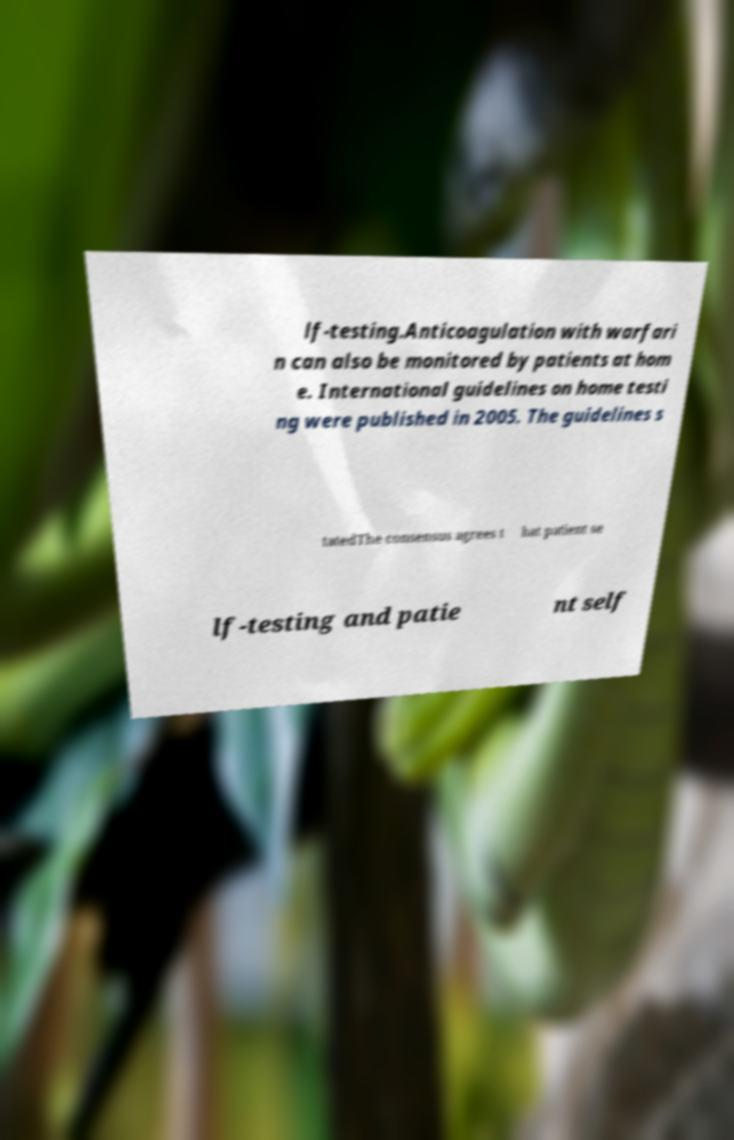Please read and relay the text visible in this image. What does it say? lf-testing.Anticoagulation with warfari n can also be monitored by patients at hom e. International guidelines on home testi ng were published in 2005. The guidelines s tatedThe consensus agrees t hat patient se lf-testing and patie nt self 